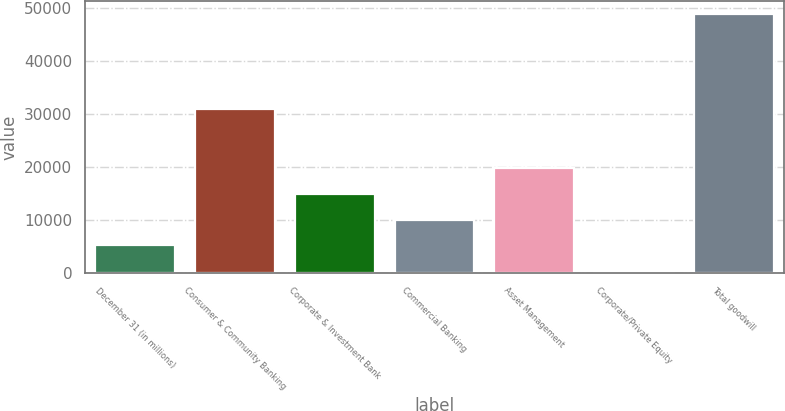Convert chart to OTSL. <chart><loc_0><loc_0><loc_500><loc_500><bar_chart><fcel>December 31 (in millions)<fcel>Consumer & Community Banking<fcel>Corporate & Investment Bank<fcel>Commercial Banking<fcel>Asset Management<fcel>Corporate/Private Equity<fcel>Total goodwill<nl><fcel>5224.7<fcel>31018<fcel>14920.1<fcel>10072.4<fcel>19767.8<fcel>377<fcel>48854<nl></chart> 